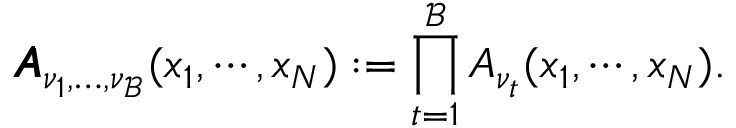Convert formula to latex. <formula><loc_0><loc_0><loc_500><loc_500>\pm b { A } _ { \nu _ { 1 } , \dots , \nu _ { \mathcal { B } } } ( x _ { 1 } , \cdots , x _ { N } ) \colon = \prod _ { t = 1 } ^ { \mathcal { B } } A _ { \nu _ { t } } ( x _ { 1 } , \cdots , x _ { N } ) .</formula> 